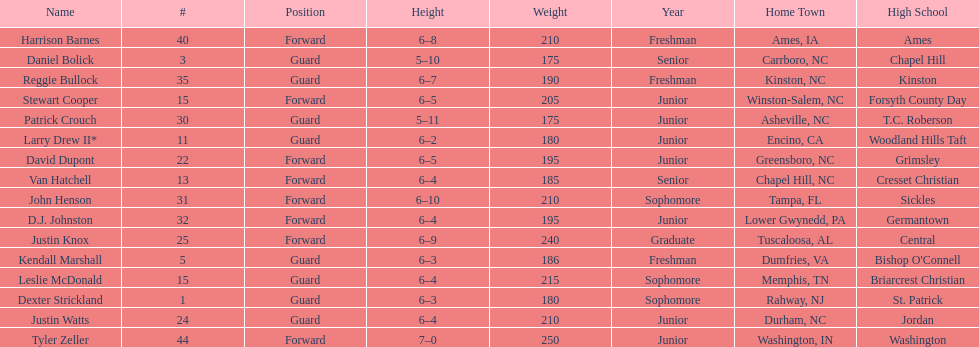Can you list the players with a height of exactly 6'4" and weighing less than 200 lbs? Van Hatchell, D.J. Johnston. 